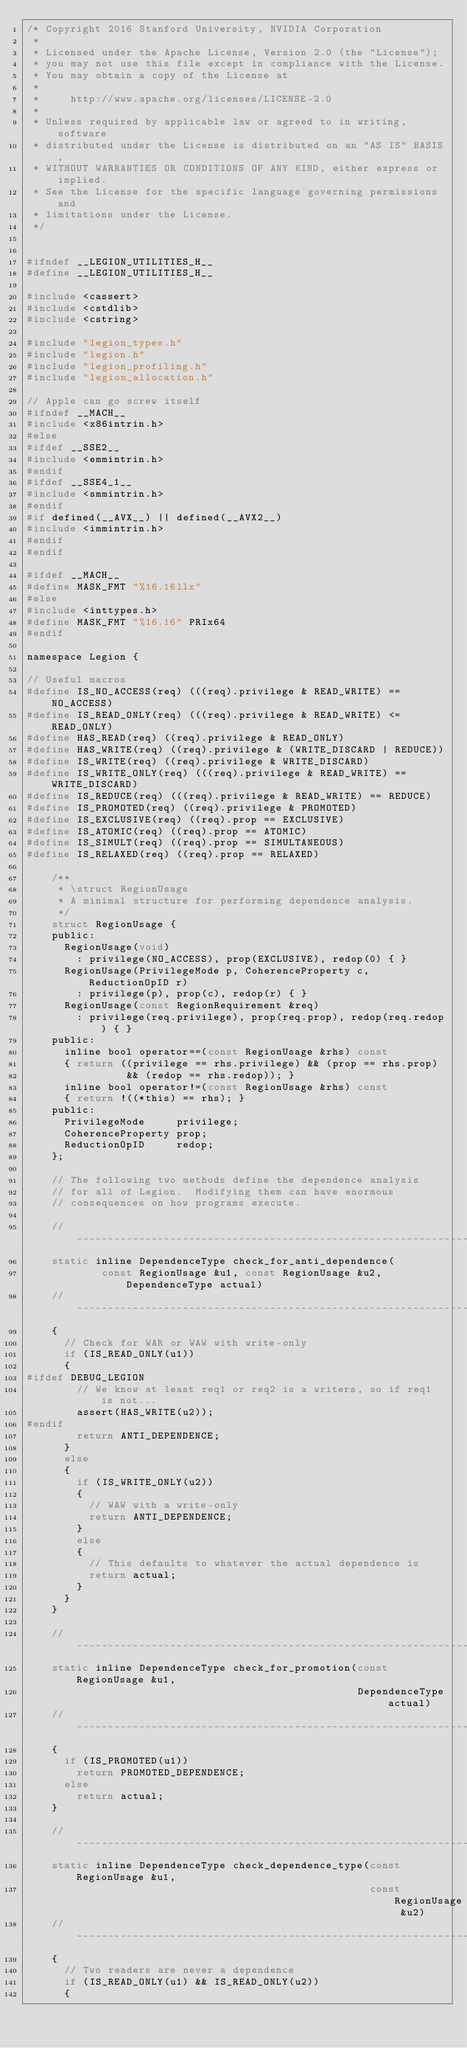<code> <loc_0><loc_0><loc_500><loc_500><_C_>/* Copyright 2016 Stanford University, NVIDIA Corporation
 *
 * Licensed under the Apache License, Version 2.0 (the "License");
 * you may not use this file except in compliance with the License.
 * You may obtain a copy of the License at
 *
 *     http://www.apache.org/licenses/LICENSE-2.0
 *
 * Unless required by applicable law or agreed to in writing, software
 * distributed under the License is distributed on an "AS IS" BASIS,
 * WITHOUT WARRANTIES OR CONDITIONS OF ANY KIND, either express or implied.
 * See the License for the specific language governing permissions and
 * limitations under the License.
 */


#ifndef __LEGION_UTILITIES_H__
#define __LEGION_UTILITIES_H__

#include <cassert>
#include <cstdlib>
#include <cstring>

#include "legion_types.h"
#include "legion.h"
#include "legion_profiling.h"
#include "legion_allocation.h"

// Apple can go screw itself
#ifndef __MACH__
#include <x86intrin.h>
#else
#ifdef __SSE2__
#include <emmintrin.h>
#endif
#ifdef __SSE4_1__
#include <smmintrin.h>
#endif
#if defined(__AVX__) || defined(__AVX2__)
#include <immintrin.h>
#endif
#endif

#ifdef __MACH__
#define MASK_FMT "%16.16llx"
#else
#include <inttypes.h>
#define MASK_FMT "%16.16" PRIx64
#endif

namespace Legion {

// Useful macros
#define IS_NO_ACCESS(req) (((req).privilege & READ_WRITE) == NO_ACCESS)
#define IS_READ_ONLY(req) (((req).privilege & READ_WRITE) <= READ_ONLY)
#define HAS_READ(req) ((req).privilege & READ_ONLY)
#define HAS_WRITE(req) ((req).privilege & (WRITE_DISCARD | REDUCE))
#define IS_WRITE(req) ((req).privilege & WRITE_DISCARD)
#define IS_WRITE_ONLY(req) (((req).privilege & READ_WRITE) == WRITE_DISCARD)
#define IS_REDUCE(req) (((req).privilege & READ_WRITE) == REDUCE)
#define IS_PROMOTED(req) ((req).privilege & PROMOTED)
#define IS_EXCLUSIVE(req) ((req).prop == EXCLUSIVE)
#define IS_ATOMIC(req) ((req).prop == ATOMIC)
#define IS_SIMULT(req) ((req).prop == SIMULTANEOUS)
#define IS_RELAXED(req) ((req).prop == RELAXED)

    /**
     * \struct RegionUsage
     * A minimal structure for performing dependence analysis.
     */
    struct RegionUsage {
    public:
      RegionUsage(void)
        : privilege(NO_ACCESS), prop(EXCLUSIVE), redop(0) { }
      RegionUsage(PrivilegeMode p, CoherenceProperty c, ReductionOpID r)
        : privilege(p), prop(c), redop(r) { }
      RegionUsage(const RegionRequirement &req)
        : privilege(req.privilege), prop(req.prop), redop(req.redop) { }
    public:
      inline bool operator==(const RegionUsage &rhs) const
      { return ((privilege == rhs.privilege) && (prop == rhs.prop) 
                && (redop == rhs.redop)); }
      inline bool operator!=(const RegionUsage &rhs) const
      { return !((*this) == rhs); }
    public:
      PrivilegeMode     privilege;
      CoherenceProperty prop;
      ReductionOpID     redop;
    };

    // The following two methods define the dependence analysis
    // for all of Legion.  Modifying them can have enormous
    // consequences on how programs execute.

    //--------------------------------------------------------------------------
    static inline DependenceType check_for_anti_dependence(
            const RegionUsage &u1, const RegionUsage &u2, DependenceType actual)
    //--------------------------------------------------------------------------
    {
      // Check for WAR or WAW with write-only
      if (IS_READ_ONLY(u1))
      {
#ifdef DEBUG_LEGION
        // We know at least req1 or req2 is a writers, so if req1 is not...
        assert(HAS_WRITE(u2)); 
#endif
        return ANTI_DEPENDENCE;
      }
      else
      {
        if (IS_WRITE_ONLY(u2))
        {
          // WAW with a write-only
          return ANTI_DEPENDENCE;
        }
        else
        {
          // This defaults to whatever the actual dependence is
          return actual;
        }
      }
    }

    //--------------------------------------------------------------------------
    static inline DependenceType check_for_promotion(const RegionUsage &u1, 
                                                     DependenceType actual)
    //--------------------------------------------------------------------------
    {
      if (IS_PROMOTED(u1))
        return PROMOTED_DEPENDENCE;
      else
        return actual;
    }

    //--------------------------------------------------------------------------
    static inline DependenceType check_dependence_type(const RegionUsage &u1,
                                                       const RegionUsage &u2)
    //--------------------------------------------------------------------------
    {
      // Two readers are never a dependence
      if (IS_READ_ONLY(u1) && IS_READ_ONLY(u2))
      {</code> 